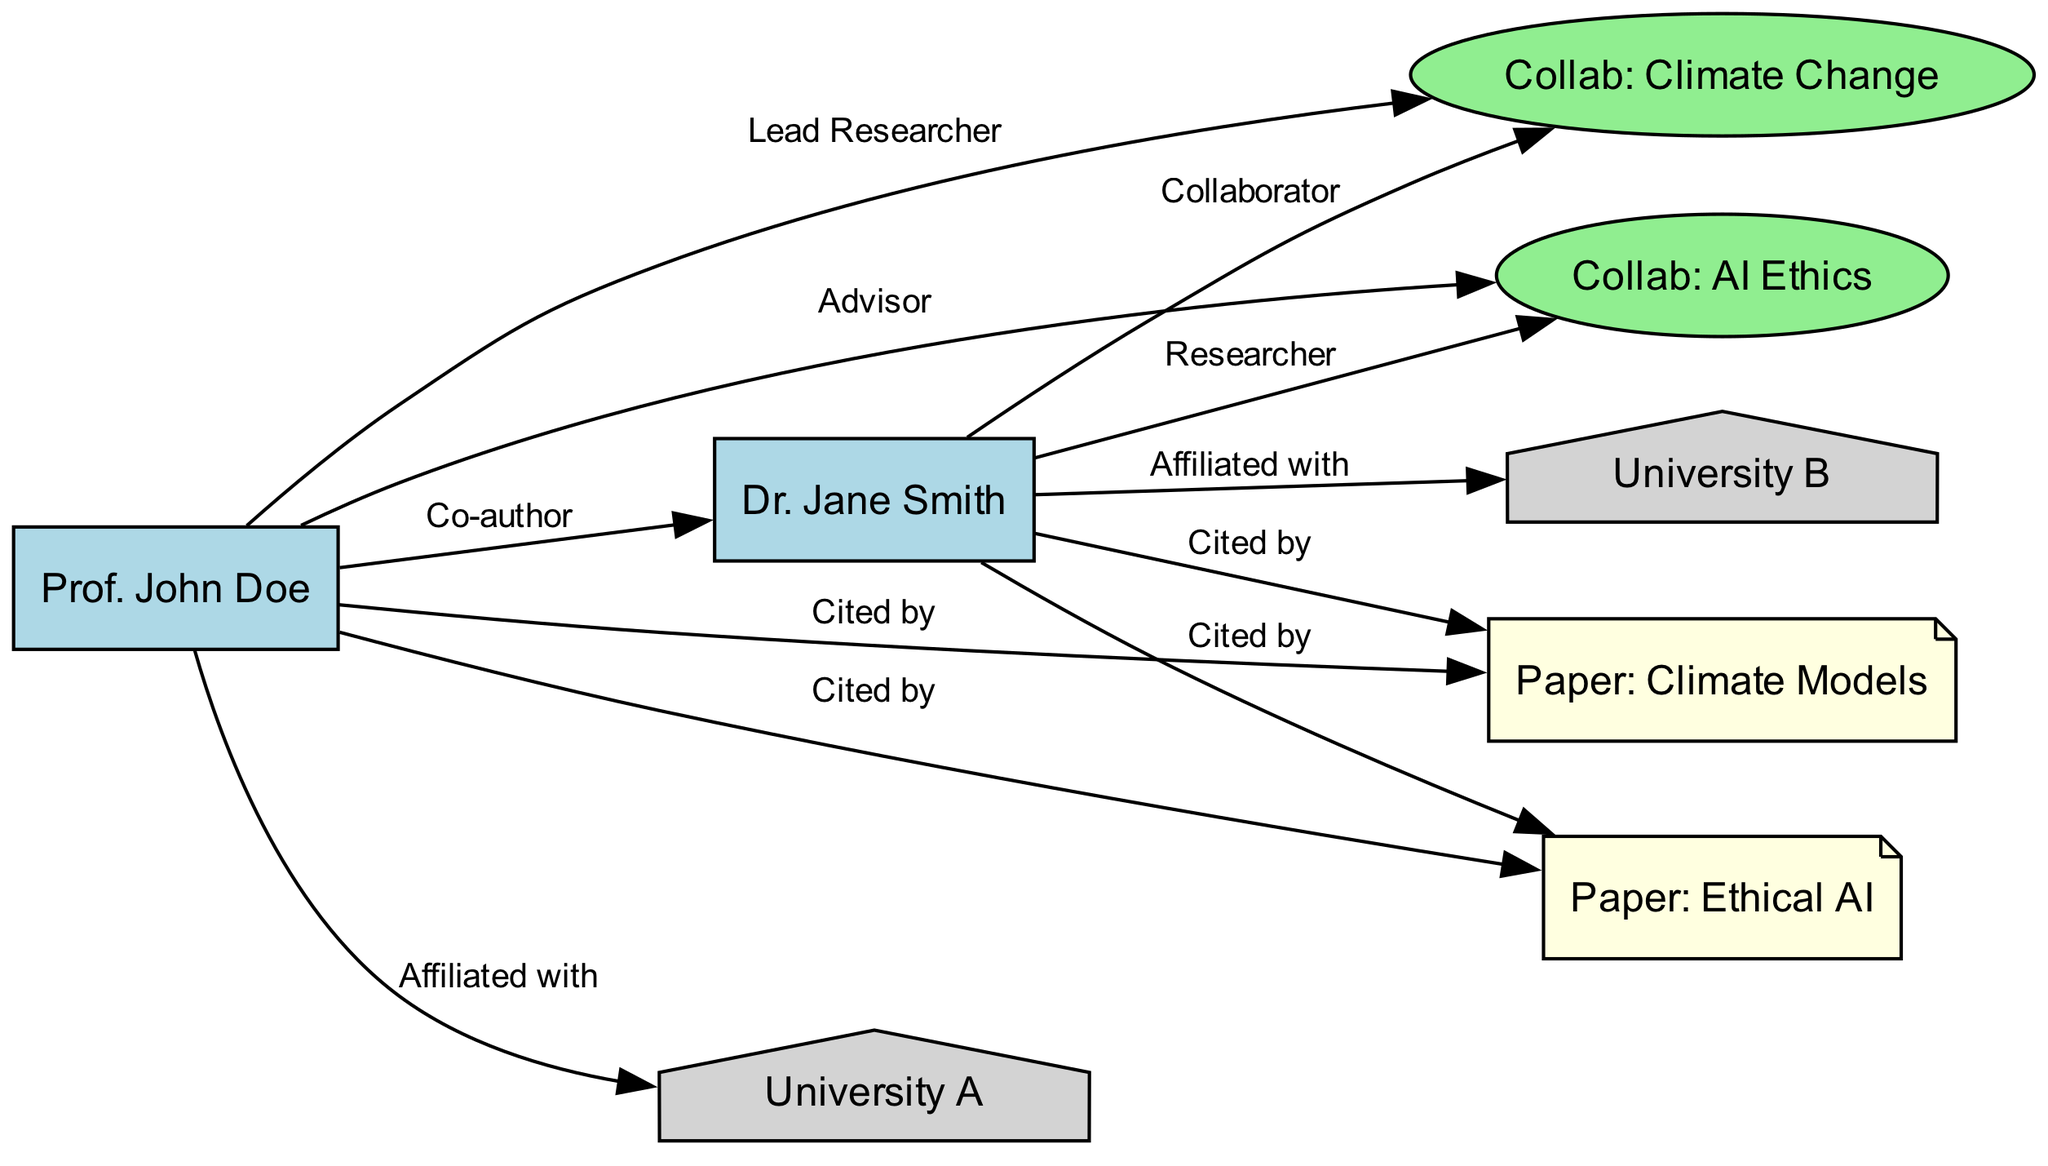What is the title of the collaboration lead by Prof. John Doe? The edge connecting "JohnDoe" to "Collaboration1" indicates he is the lead researcher of this collaboration, labeled as "Collab: Climate Change."
Answer: Collab: Climate Change How many co-authors does Dr. Jane Smith have in total? There is an edge between "JohnDoe" and "JaneSmith," indicating they are co-authors. Therefore, Dr. Jane Smith has one co-author: Prof. John Doe.
Answer: 1 Which university is Prof. John Doe affiliated with? The edge connecting "JohnDoe" to "UniversityA" shows that Prof. John Doe is affiliated with University A.
Answer: University A How many papers are cited by both researchers? There are two edges connecting both "JohnDoe" and "JaneSmith" to "Citation1" and "Citation2," indicating they both cited these two papers. Therefore, there are two papers cited by both.
Answer: 2 What role does Dr. Jane Smith have in the collaboration related to AI Ethics? The edge from "JaneSmith" to "Collaboration2" indicates her role as a researcher in this collaboration.
Answer: Researcher Which type of nodes do the universities represent? The nodes labeled "University A" and "University B" are defined as houses in the diagram, indicating their type.
Answer: House How many collaborations are represented in the diagram? There are two collaboration nodes: "Collab: Climate Change" and "Collab: AI Ethics," indicating there are two collaborations represented in the diagram.
Answer: 2 Which paper is associated with climate models as cited by both researchers? The node labeled "Citation1" is noted as "Paper: Climate Models," which is cited by both researchers, as indicated by the edges from both "JohnDoe" and "JaneSmith."
Answer: Paper: Climate Models What is the relationship between Prof. John Doe and Dr. Jane Smith? The edge from "JohnDoe" to "JaneSmith" labeled "Co-author" indicates that they share a co-author relationship.
Answer: Co-author 